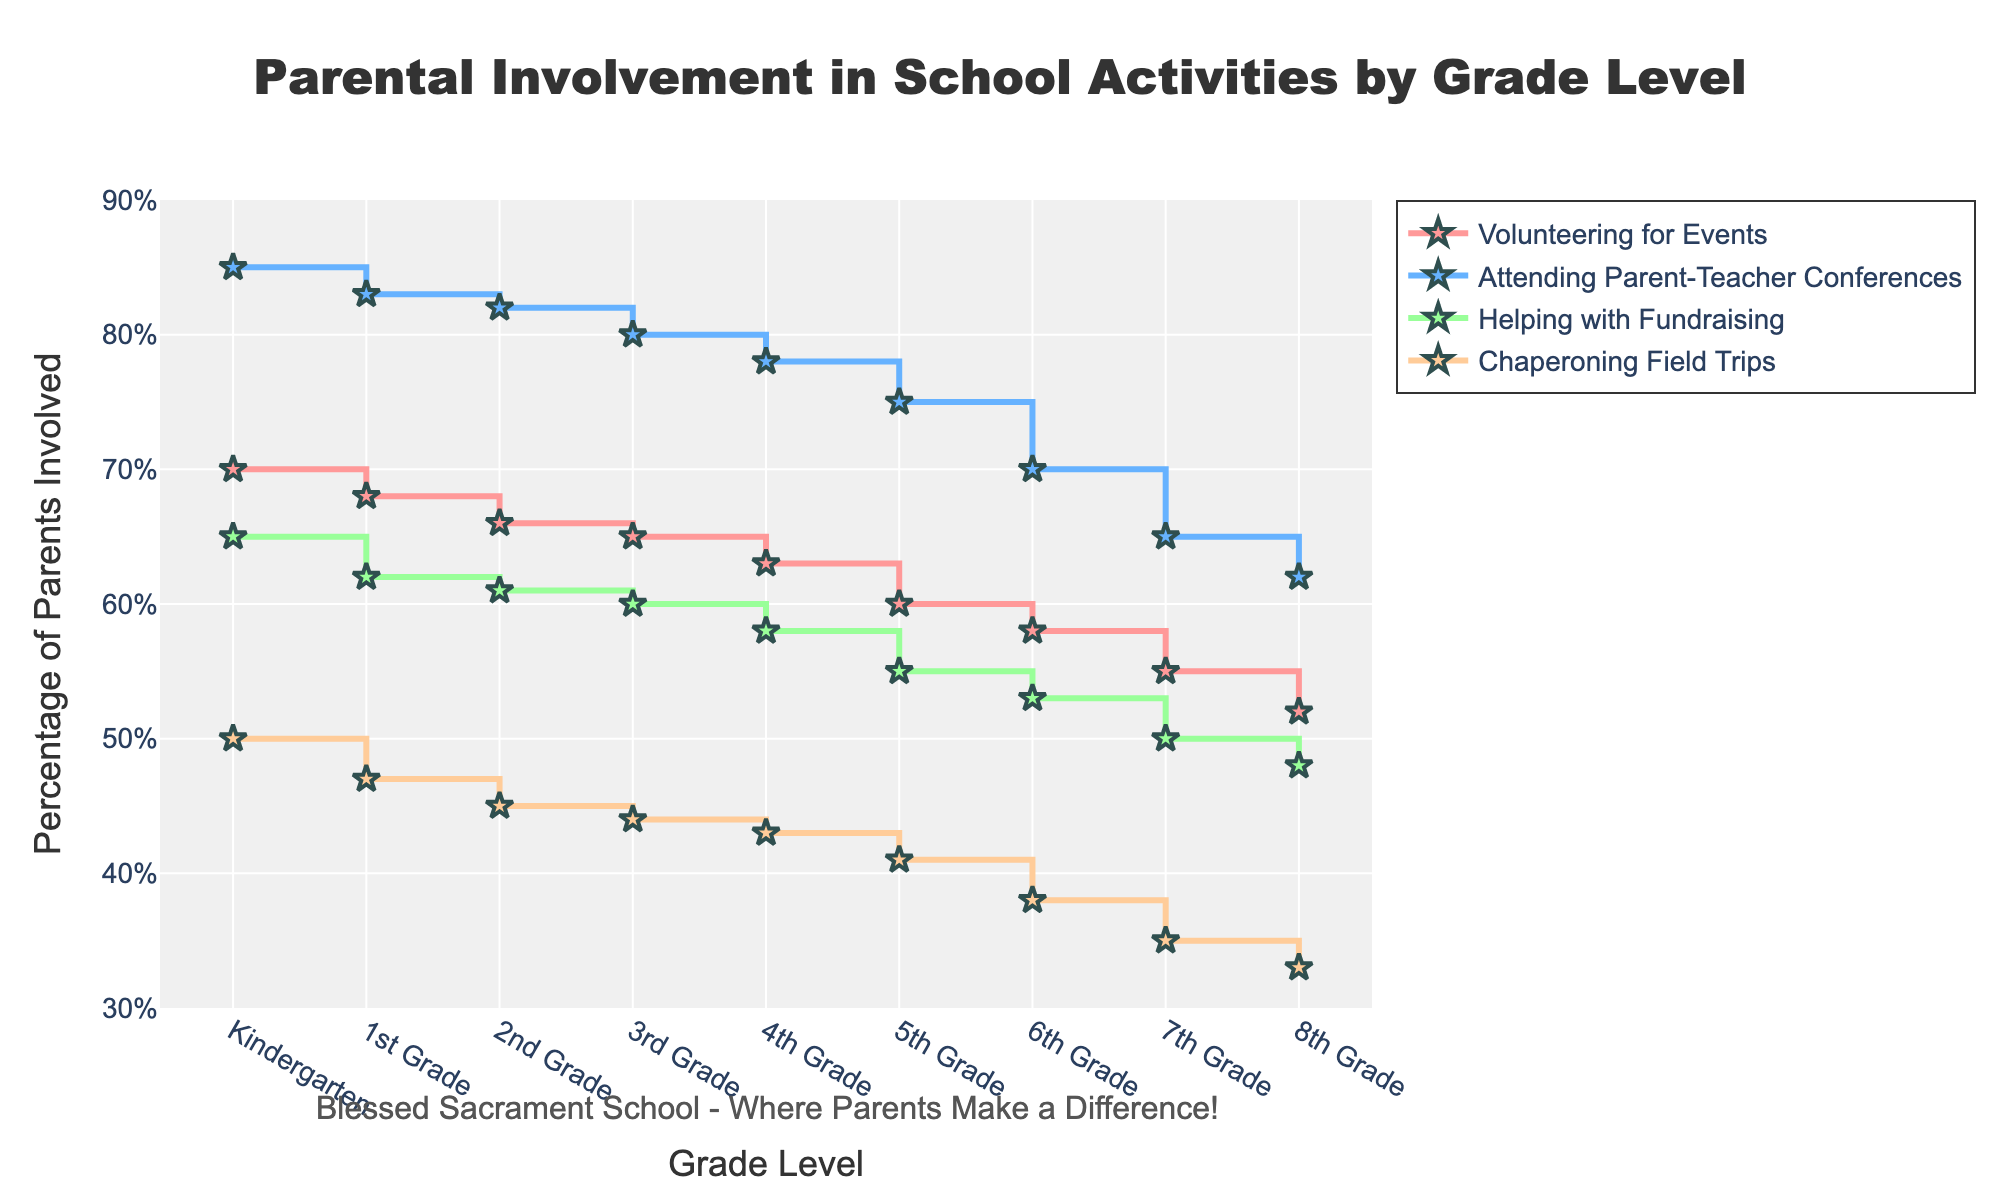what is the primary focus of the plot? The title of the plot "Parental Involvement in School Activities by Grade Level" indicates that it shows the level of parental involvement in different school activities across various grade levels.
Answer: Parental Involvement in School Activities by Grade Level which grade level has the highest percentage of parents volunteering for events? By looking at the line associated with "Volunteering for Events," we can see that Kindergarten has the highest percentage at 70%.
Answer: Kindergarten how does the percentage of parents attending parent-teacher conferences change from kindergarten to 8th grade? Observing the line for "Attending Parent-Teacher Conferences," we see that it starts at 85% in Kindergarten and decreases steadily to 62% in 8th Grade.
Answer: It decreases from 85% to 62% which activity has the highest parental involvement in the Kindergarten grade? By examining the four lines at the Kindergarten grade, "Attending Parent-Teacher Conferences" has the highest value at 85%.
Answer: Attending Parent-Teacher Conferences compare the trend of parental involvement in chaperoning field trips and helping with fundraising. which one shows a steeper decline from kindergarten to 8th grade? The lines for both activities decline, but "Chaperoning Field Trips" starts at 50% and ends at 33%, a decrease of 17%. "Helping with Fundraising" starts at 65% and ends at 48%, a decrease of 17%. Since both show the same decline in percentage, neither is steeper.
Answer: Both show the same decline based on the plot, which school activity has the least involvement from kindergarten to 8th grade? By comparing all four lines, "Chaperoning Field Trips" has the lowest percentage of parental involvement across all grades.
Answer: Chaperoning Field Trips what is the percentage difference in parental involvement between kindergarten and 5th grade for helping with fundraising? We note the values for "Helping with Fundraising" at Kindergarten (65%) and 5th Grade (55%). The difference is 65% - 55% = 10%.
Answer: 10% which grade level marks the largest drop in parental involvement across all activities? By examining the grades, the largest drop-off is generally seen from Kindergarten to 1st Grade for most activities, though the steepest individual decline is from 6th to 7th grade for "Attending Parent-Teacher Conferences."
Answer: 6th to 7th Grade what is the common trend in parental involvement for all activities from kindergarten to 8th grade? All lines for the activities show a downward trend, indicating that parental involvement decreases steadily as children progress from Kindergarten to 8th Grade.
Answer: Decreasing trend 